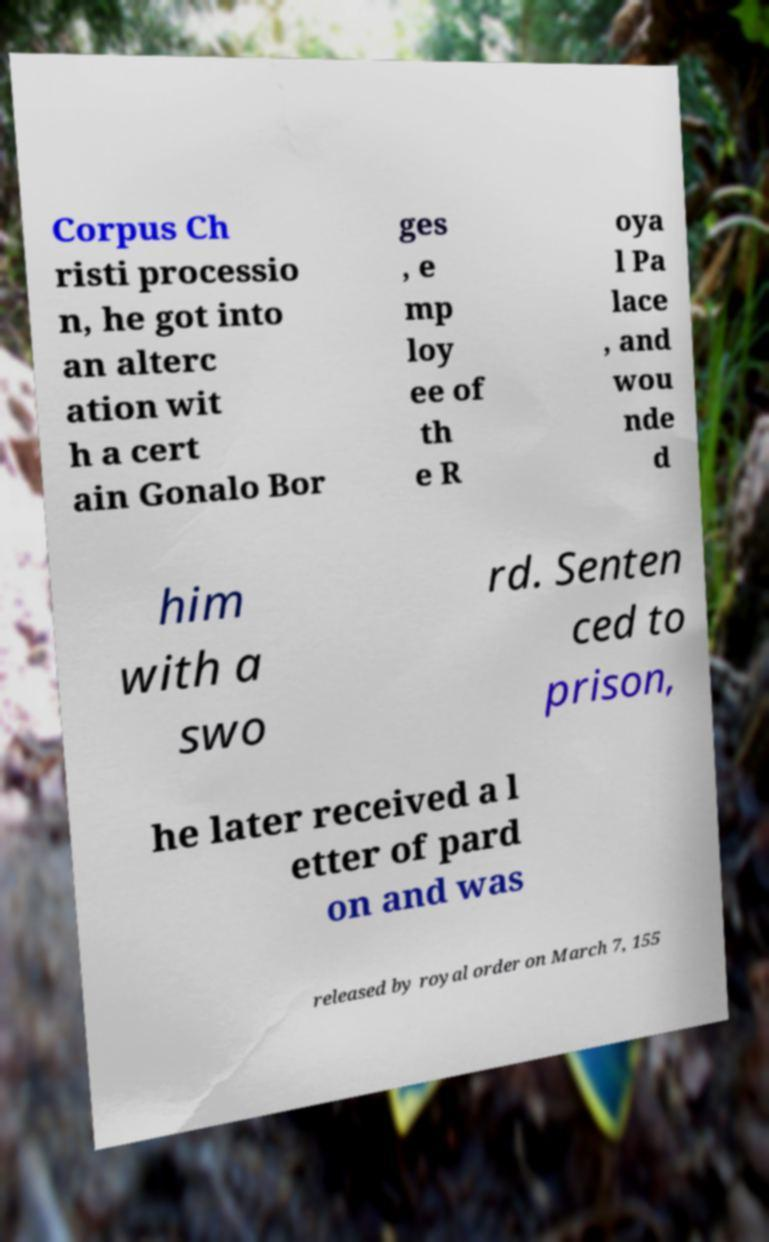What messages or text are displayed in this image? I need them in a readable, typed format. Corpus Ch risti processio n, he got into an alterc ation wit h a cert ain Gonalo Bor ges , e mp loy ee of th e R oya l Pa lace , and wou nde d him with a swo rd. Senten ced to prison, he later received a l etter of pard on and was released by royal order on March 7, 155 